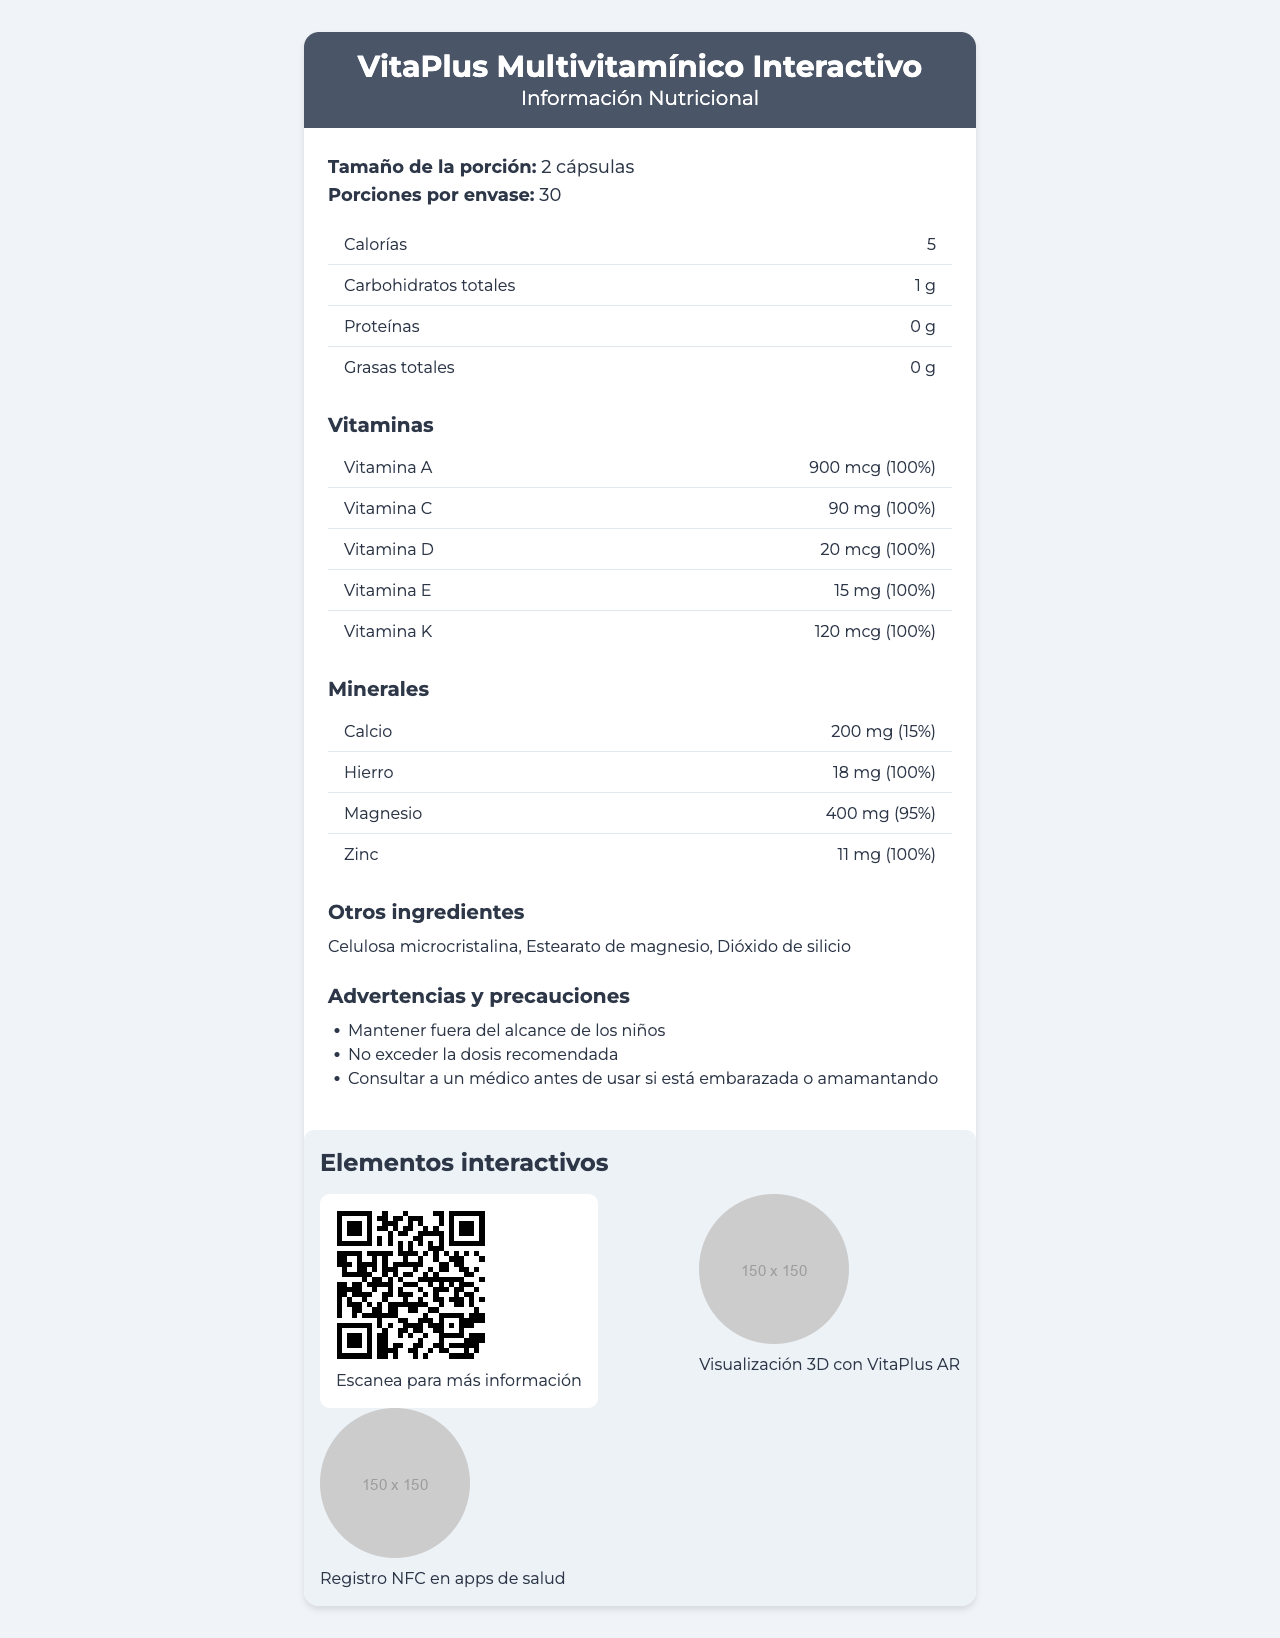what is the serving size for VitaPlus Multivitamínico Interactivo? The document states that the serving size is 2 cápsulas.
Answer: 2 cápsulas how many servings are there per container? The document mentions that there are 30 servings per container.
Answer: 30 how many calories are in a serving? The document specifies that each serving contains 5 calories.
Answer: 5 what is the amount of Vitamina C in one serving? The nutrition label shows that one serving includes 90 mg of Vitamina C.
Answer: 90 mg list the other ingredients present in the product The document lists the other ingredients as Celulosa microcristalina, Estearato de magnesio, and Dióxido de silicio.
Answer: Celulosa microcristalina, Estearato de magnesio, Dióxido de silicio which vitamin has the highest daily value percentage? A. Vitamina A B. Vitamina C C. Vitamina D D. Vitamina K Vitamina A, Vitamina C, Vitamina D, and Vitamina E all have a daily value percentage of 100%, but it's higher in micrograms for Vitamina A.
Answer: A which mineral is present in a quantity of 400 mg per serving? A. Calcio B. Hierro C. Magnesio D. Zinc The document states that Magnesio is present in a quantity of 400 mg per serving.
Answer: C is the product recommended for children? The warnings and precautions state to keep the product out of the reach of children.
Answer: No does the document include information on how to personalize the user experience based on health goals? Under the UX benefits section, it mentions personalizing the user experience based on health goals.
Answer: Yes describe the main purpose of the VitaPlus Multivitamínico Interactivo label The document contains the product name, serving size, nutritional information (including vitamins and minerals), other ingredients, warnings, interactive elements, design considerations, and user experience benefits.
Answer: The label provides detailed nutritional information, warnings, and interactive elements to help the user understand and manage their vitamin and mineral intake using a combination of physical and digital interfaces. what is the exact URL for scanning the QR code on the label? The interactive elements section specifies that the QR code links to https://vitaplus.com/multivitaminico-info.
Answer: https://vitaplus.com/multivitaminico-info what are some compatible apps for the NFC tag mentioned on the label? The interactive elements section mentions that the NFC Tag is compatible with Apple Health, Google Fit, and Samsung Health.
Answer: Apple Health, Google Fit, Samsung Health which app is required for the 3D visualization of nutrient absorption? The interactive elements section specifies that the VitaPlus AR app is required for 3D visualization of nutrient absorption.
Answer: VitaPlus AR does the label mention anything about the product's effect on energy levels? The document does not provide specific information about the product's effect on energy levels.
Answer: Not enough information 